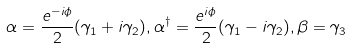Convert formula to latex. <formula><loc_0><loc_0><loc_500><loc_500>\alpha = \frac { e ^ { - i \phi } } { 2 } ( \gamma _ { 1 } + i \gamma _ { 2 } ) , \alpha ^ { \dagger } = \frac { e ^ { i \phi } } { 2 } ( \gamma _ { 1 } - i \gamma _ { 2 } ) , \beta = \gamma _ { 3 }</formula> 